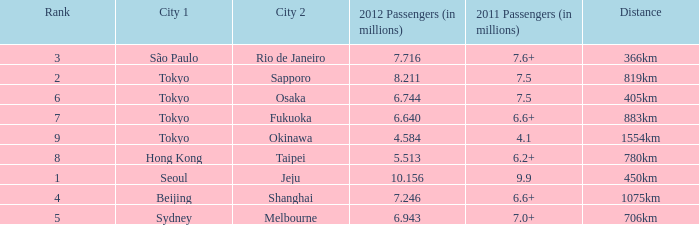How many passengers (in millions) in 2011 flew through along the route that had 6.640 million passengers in 2012? 6.6+. 